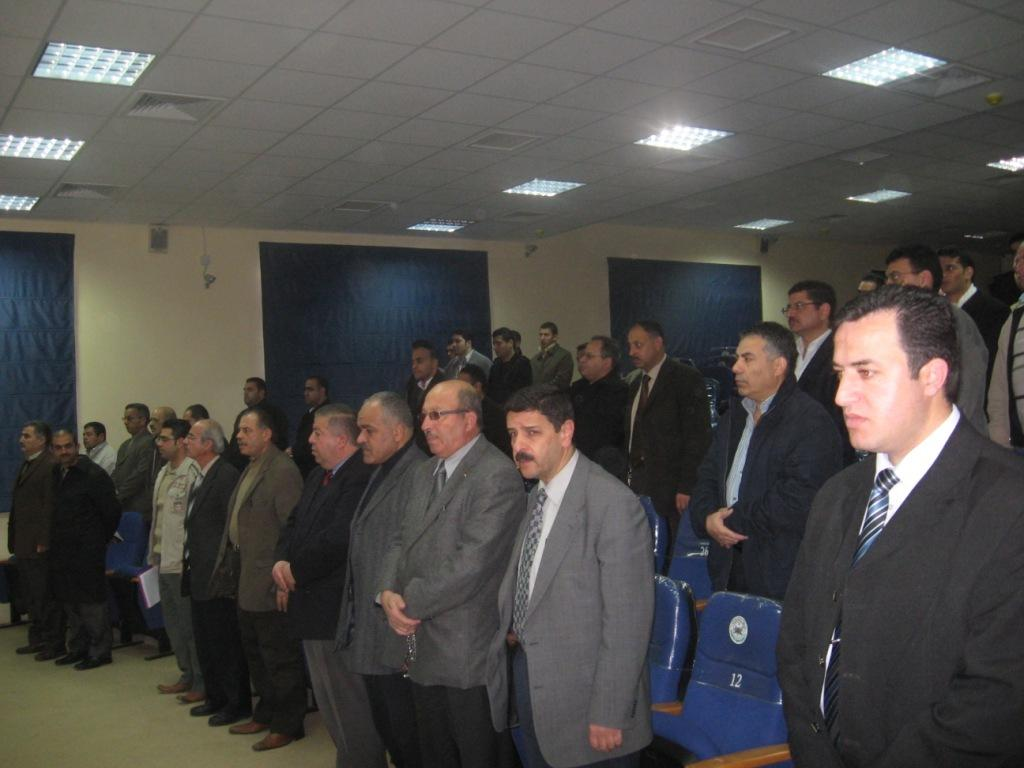What can be seen in the image involving multiple individuals? There is a group of people in the image. What objects are present that might be used for sitting? There are chairs in the image. What is visible at the top of the image? There are lights visible at the top of the image. How many trees can be seen in the image? There are no trees visible in the image. What type of mark is present on the chairs in the image? There is no mention of any marks on the chairs in the image. 